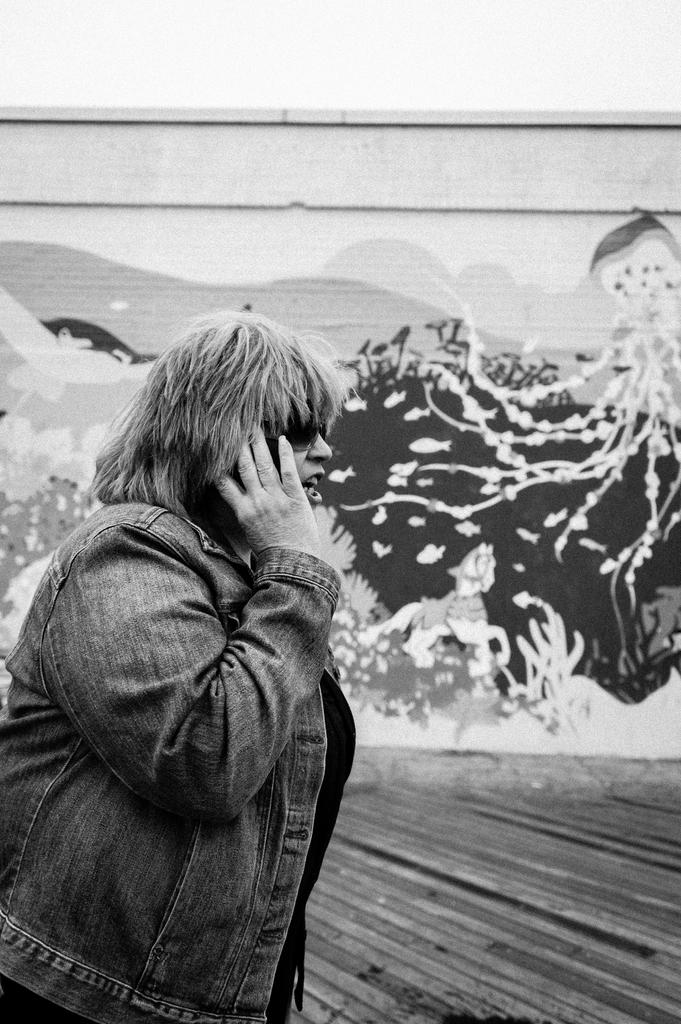What is the color scheme of the image? The image is black and white. Can you describe the main subject in the image? There is a person in the image. What can be seen on the wall behind the person? There is a painting on the wall behind the person. What is visible at the top of the image? The sky is visible at the top of the image. Where is the crate of cabbages located in the image? There is no crate of cabbages present in the image. What type of door can be seen in the image? There is no door visible in the image. 